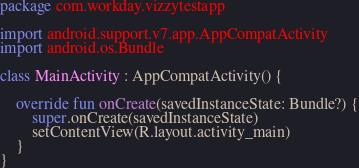<code> <loc_0><loc_0><loc_500><loc_500><_Kotlin_>package com.workday.vizzytestapp

import android.support.v7.app.AppCompatActivity
import android.os.Bundle

class MainActivity : AppCompatActivity() {

    override fun onCreate(savedInstanceState: Bundle?) {
        super.onCreate(savedInstanceState)
        setContentView(R.layout.activity_main)
    }
}
</code> 